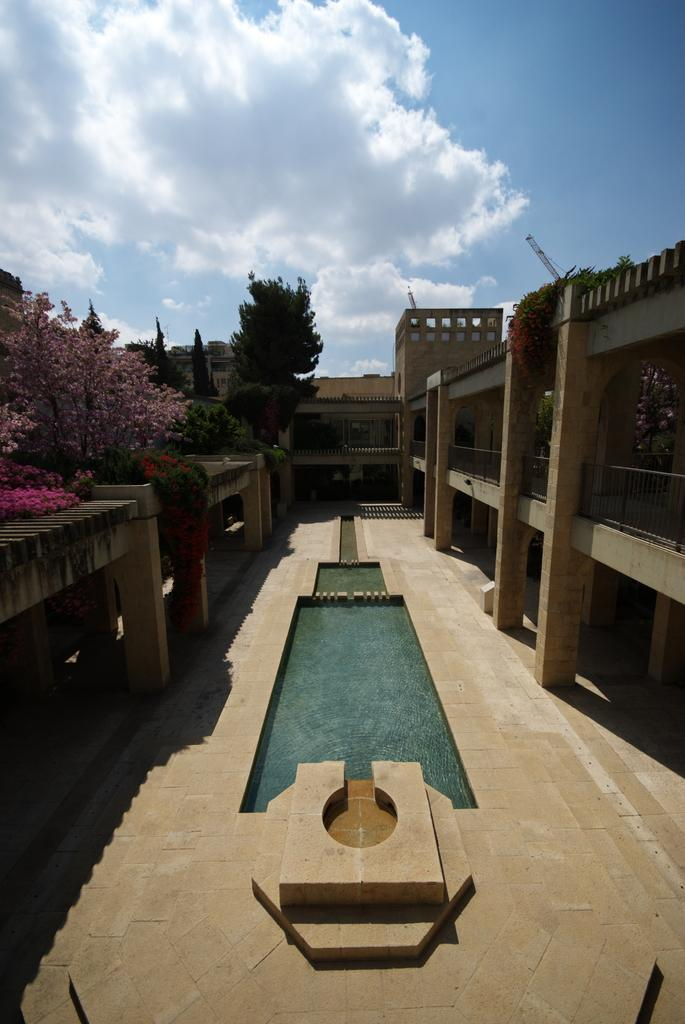What type of terrain is visible in the image? There is ground visible in the image. What natural element is also present in the image? There is water visible in the image. What type of vegetation can be seen in the image? There are green trees and pink trees in the image. Are there any man-made structures visible in the image? Yes, there are buildings in the image. What can be seen in the background of the image? The sky is visible in the background of the image. What type of icicle can be seen hanging from the buildings in the image? There are no icicles present in the image; it is not cold enough for icicles to form. What type of marble is visible in the image? There is no marble present in the image; it features ground, water, trees, buildings, and sky. 